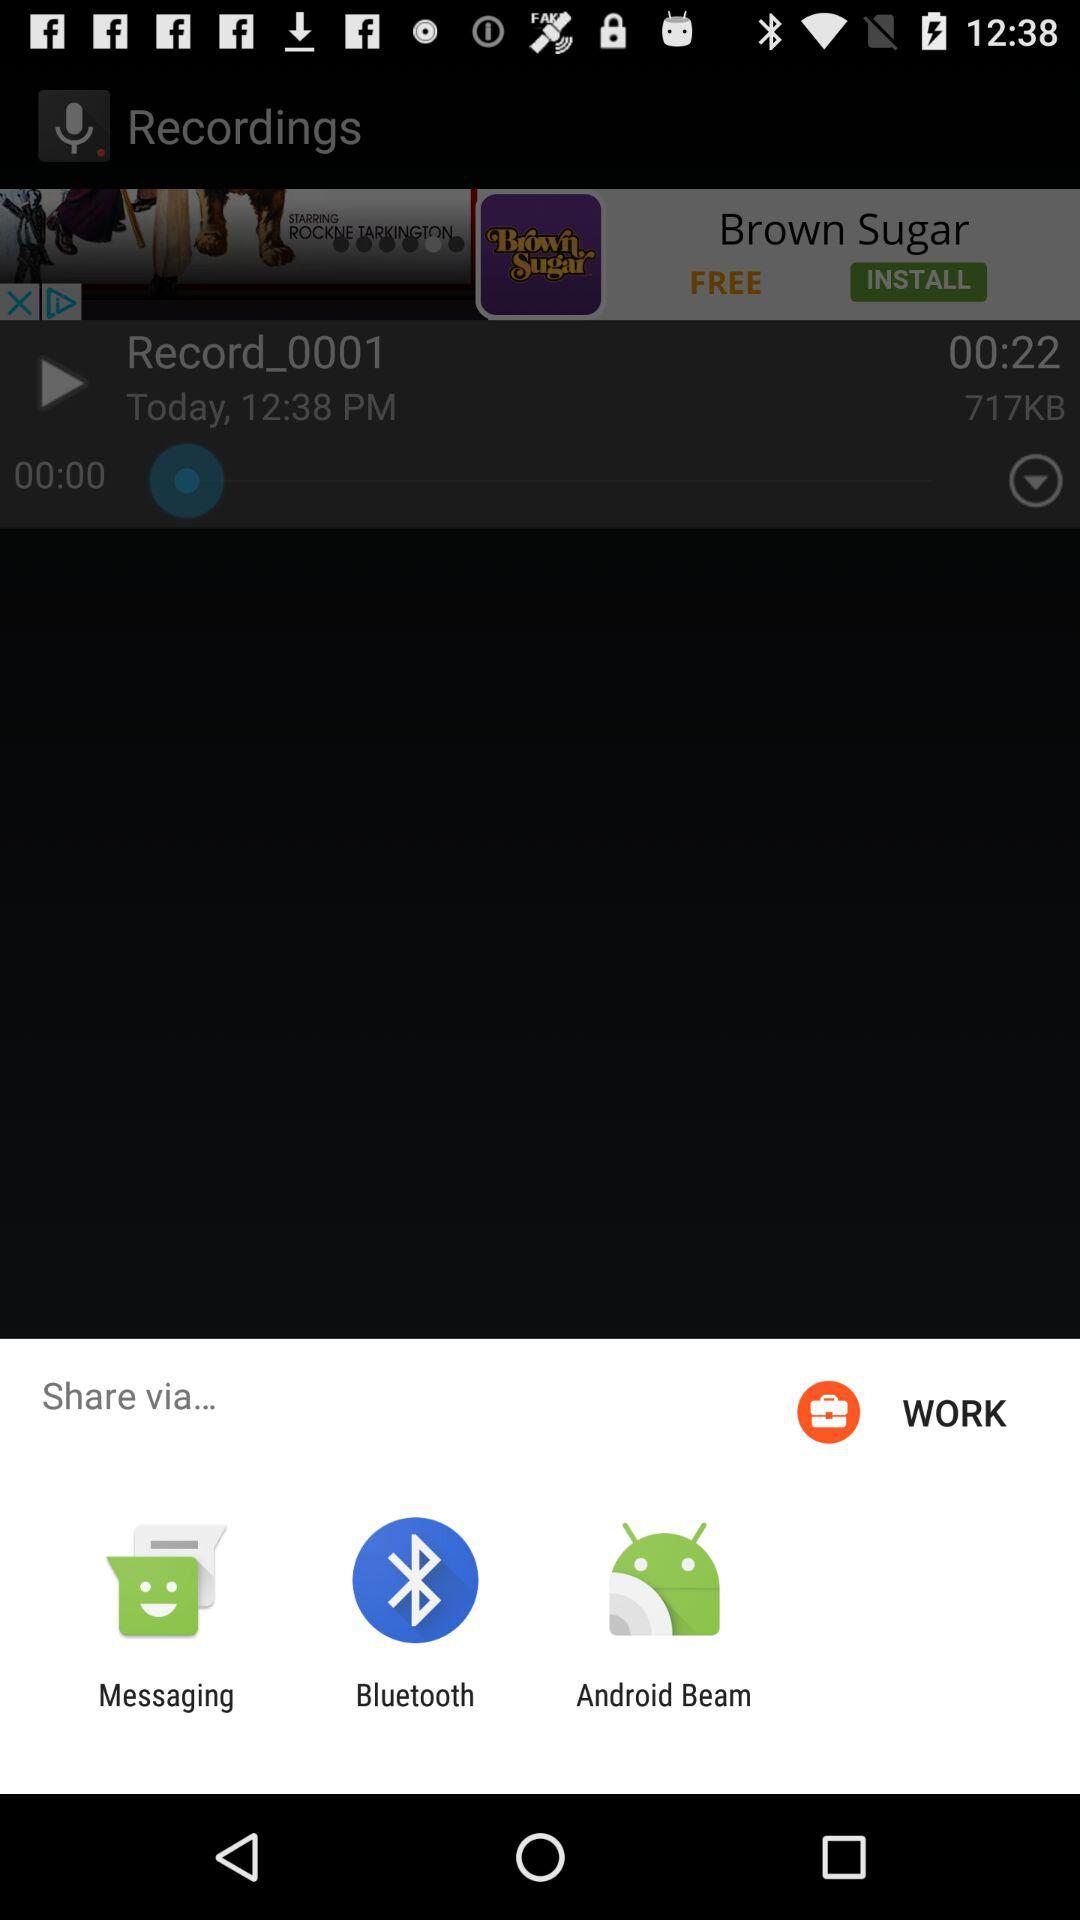How many more seconds are there in the recording than in the playback?
Answer the question using a single word or phrase. 22 